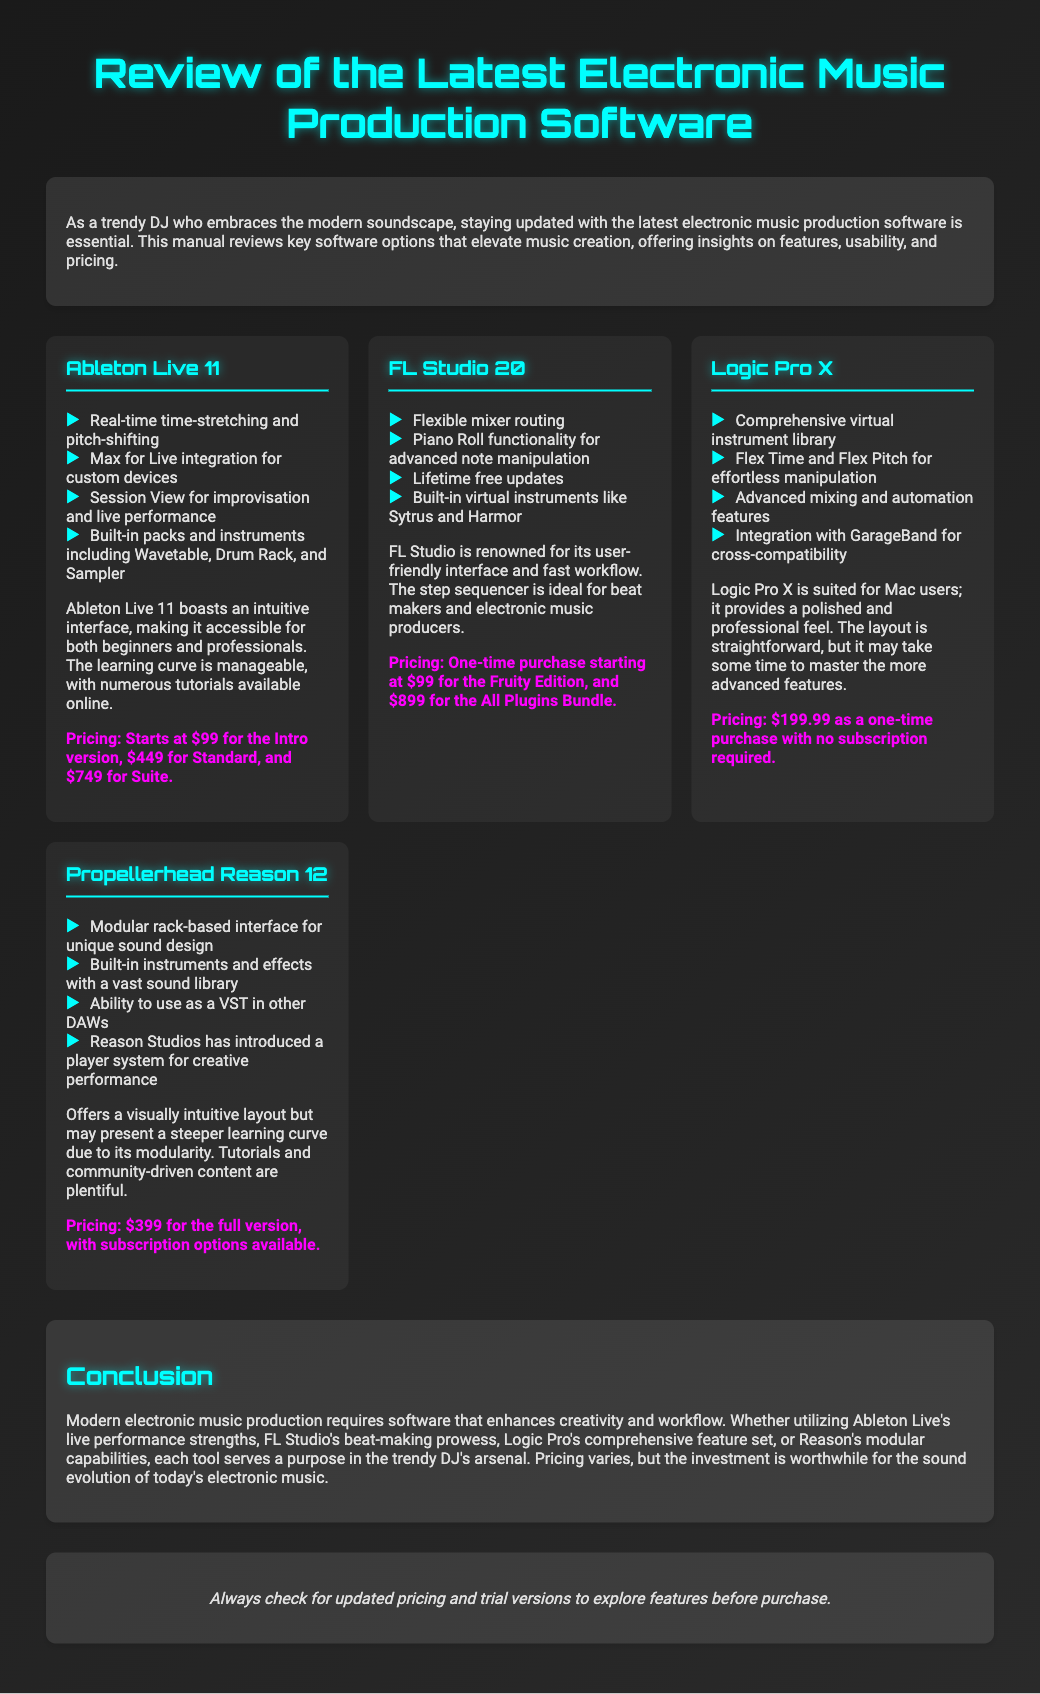What is the name of the production software that starts at $99? Ableton Live 11 is noted for its introductory pricing of $99 in the document.
Answer: Ableton Live 11 How many editions does FL Studio 20 offer? The document states that FL Studio 20 has different offerings, including the Fruity Edition and All Plugins Bundle, indicating multiple editions exist.
Answer: Two What is the one-time purchase price of Logic Pro X? The document explicitly mentions that Logic Pro X is available for a one-time purchase of $199.99.
Answer: $199.99 Which software has built-in virtual instruments like Sytrus? FL Studio 20 is highlighted for having built-in instruments such as Sytrus and Harmor.
Answer: FL Studio 20 What feature distinguishes Ableton Live 11 from the other software? The real-time time-stretching and pitch-shifting feature set Ableton Live 11 apart according to the document's contents.
Answer: Real-time time-stretching and pitch-shifting Which software is known for its modular rack-based interface? The document specifies Propellerhead Reason 12 as having a modular rack-based interface for unique sound design.
Answer: Propellerhead Reason 12 What is the price range for Ableton Live 11's different versions? The document outlines that prices for Ableton Live 11 start at $99 for Intro, $449 for Standard, and $749 for Suite, indicating a pricing range.
Answer: $99 to $749 Is there a mention of pricing for subscription options in the document? The document specifies that Propellerhead Reason 12 has subscription options available which suggests pricing information is present related to subscriptions.
Answer: Yes, for Propellerhead Reason 12 